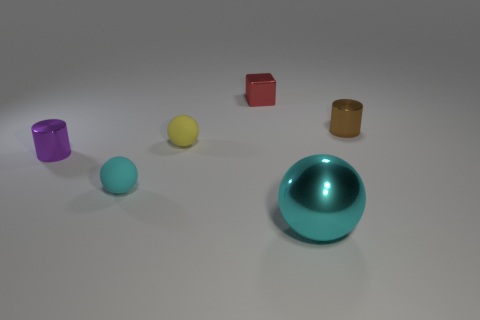How many objects are either small metal objects to the left of the block or tiny cylinders on the left side of the red metal cube?
Your answer should be very brief. 1. Do the tiny brown metallic object and the tiny shiny thing left of the red cube have the same shape?
Give a very brief answer. Yes. What shape is the tiny metal object right of the cyan thing that is in front of the cyan thing that is on the left side of the red metal cube?
Your answer should be compact. Cylinder. What number of other things are there of the same material as the yellow sphere
Your answer should be compact. 1. How many objects are either small objects left of the large metal sphere or large cyan shiny objects?
Provide a succinct answer. 5. There is a tiny thing that is in front of the metallic cylinder on the left side of the small shiny cube; what shape is it?
Your answer should be very brief. Sphere. Does the metallic object that is to the left of the small yellow rubber thing have the same shape as the tiny cyan object?
Provide a short and direct response. No. There is a tiny rubber sphere behind the small cyan rubber ball; what color is it?
Offer a very short reply. Yellow. What number of spheres are either rubber objects or tiny brown objects?
Your response must be concise. 2. There is a metallic object in front of the tiny cylinder that is on the left side of the brown metal thing; how big is it?
Keep it short and to the point. Large. 